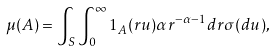<formula> <loc_0><loc_0><loc_500><loc_500>\mu ( A ) = \int _ { S } \int _ { 0 } ^ { \infty } 1 _ { A } ( r u ) \alpha r ^ { - \alpha - 1 } d r \sigma ( d u ) ,</formula> 